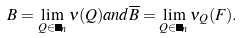Convert formula to latex. <formula><loc_0><loc_0><loc_500><loc_500>B = \lim _ { Q \in \Psi _ { n } } \nu ( Q ) a n d \overline { B } = \lim _ { Q \in \Psi _ { n } } \nu _ { Q } ( F ) .</formula> 